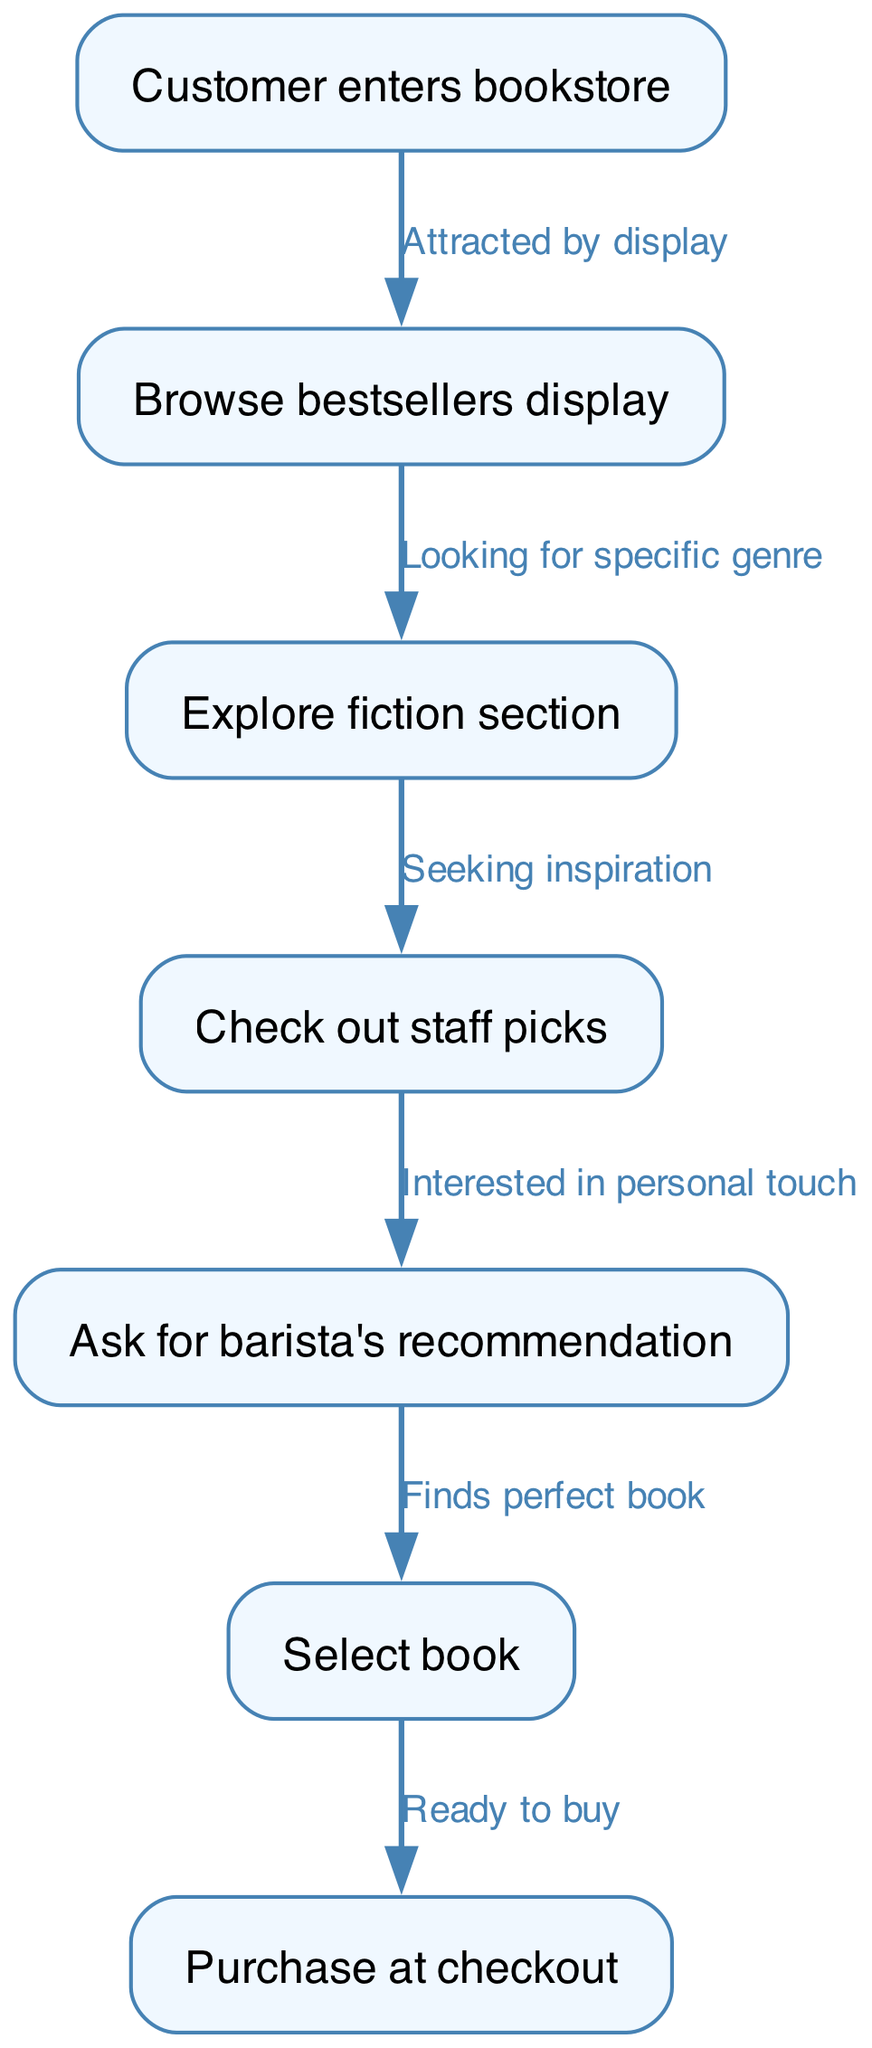What is the first step in the customer journey? The first node in the flow chart is "Customer enters bookstore," which indicates the initial action taken by the customer as they begin their journey.
Answer: Customer enters bookstore How many nodes are there in the flow chart? By counting the entries in the "nodes" array, we find there are 7 unique nodes representing different steps in the customer's journey.
Answer: 7 Which section does the customer explore after the bestsellers display? The arrow labeled "Looking for specific genre" indicates the transition from browsing bestsellers to the "Explore fiction section."
Answer: Explore fiction section What action follows checking out staff picks? According to the flow, after "Check out staff picks," the next action described is to "Ask for barista's recommendation," indicating a clear progression in the customer's journey.
Answer: Ask for barista's recommendation What is the relationship between asking for a recommendation and selecting a book? The edge labeled "Finds perfect book" indicates a direct connection from "Ask for barista's recommendation" to "Select book," illustrating that seeking a recommendation leads to book selection.
Answer: Finds perfect book What is the last step before the customer makes a purchase? The flow chart shows that the action "Ready to buy" occurs right before "Purchase at checkout," indicating the final step where the customer decides to complete the transaction.
Answer: Ready to buy After exploring the fiction section, what does the customer do? The customer transitions to the "Check out staff picks" step, as indicated by the "Seeking inspiration" label connecting these two actions in the flow chart.
Answer: Check out staff picks What guides the customer from staff picks to asking for a recommendation? The transition labeled "Interested in personal touch" directly links "Check out staff picks" to "Ask for barista's recommendation," illustrating the motivation behind this action.
Answer: Interested in personal touch 